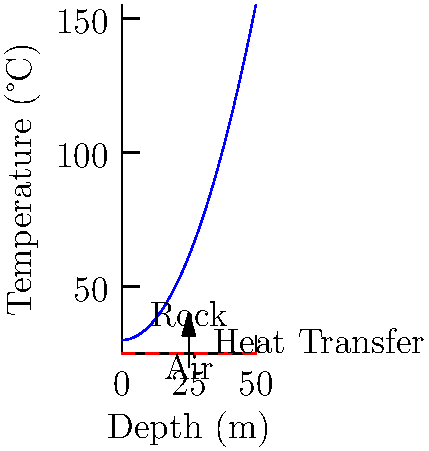In an underground mining operation, the temperature of the rock increases with depth according to the equation $T(x) = 30 + 0.05x^2$, where $T$ is the temperature in °C and $x$ is the depth in meters. The ambient air temperature at the surface is 25°C. At what depth will the rock temperature be 10°C higher than the ambient air temperature, and what is the rate of heat transfer at this point if the thermal conductivity of the rock is 3 W/(m·K)? To solve this problem, we need to follow these steps:

1) First, we need to find the depth at which the rock temperature is 10°C higher than the ambient air temperature:

   $T(x) = T_{ambient} + 10$
   $30 + 0.05x^2 = 25 + 10$
   $0.05x^2 = 5$
   $x^2 = 100$
   $x = 10$ m

2) Now that we know the depth, we can calculate the temperature gradient at this point:

   $\frac{dT}{dx} = \frac{d}{dx}(30 + 0.05x^2) = 0.1x$

   At $x = 10$ m: $\frac{dT}{dx} = 0.1 \cdot 10 = 1$ °C/m

3) The rate of heat transfer can be calculated using Fourier's law:

   $q = -k\frac{dT}{dx}$

   Where:
   $q$ is the heat flux (W/m²)
   $k$ is the thermal conductivity (W/(m·K))
   $\frac{dT}{dx}$ is the temperature gradient (K/m or °C/m)

4) Substituting the values:

   $q = -3 \cdot (-1) = 3$ W/m²

Therefore, at a depth of 10 m, the rock temperature will be 10°C higher than the ambient air temperature, and the rate of heat transfer will be 3 W/m².
Answer: Depth: 10 m, Heat transfer rate: 3 W/m² 